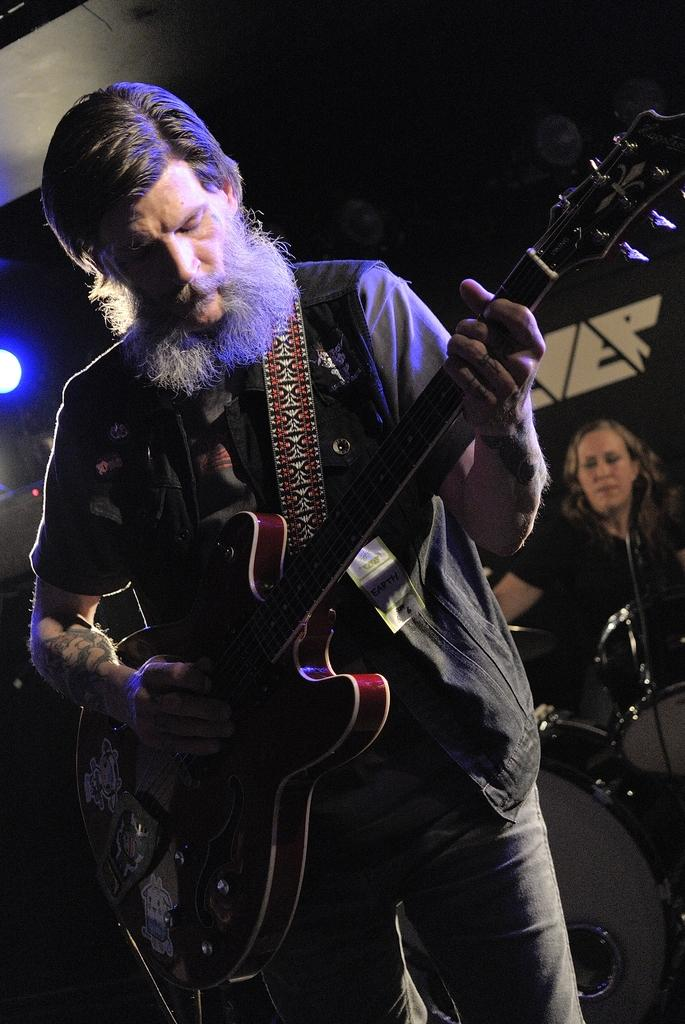What is the man in the image doing? The man is holding a guitar and playing it. What is the woman in the image doing? The woman is playing drums. What can be seen in the background of the image? The background of the image is dark, but there is light visible. How many eggs are on top of the drum set in the image? There are no eggs present in the image, and they are not on top of the drum set. 